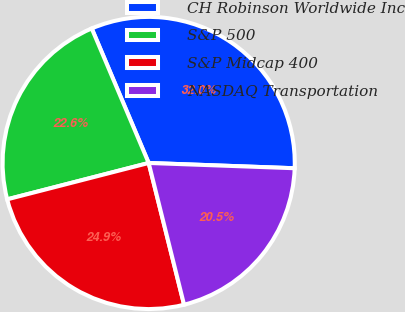<chart> <loc_0><loc_0><loc_500><loc_500><pie_chart><fcel>CH Robinson Worldwide Inc<fcel>S&P 500<fcel>S&P Midcap 400<fcel>NASDAQ Transportation<nl><fcel>31.95%<fcel>22.63%<fcel>24.89%<fcel>20.53%<nl></chart> 